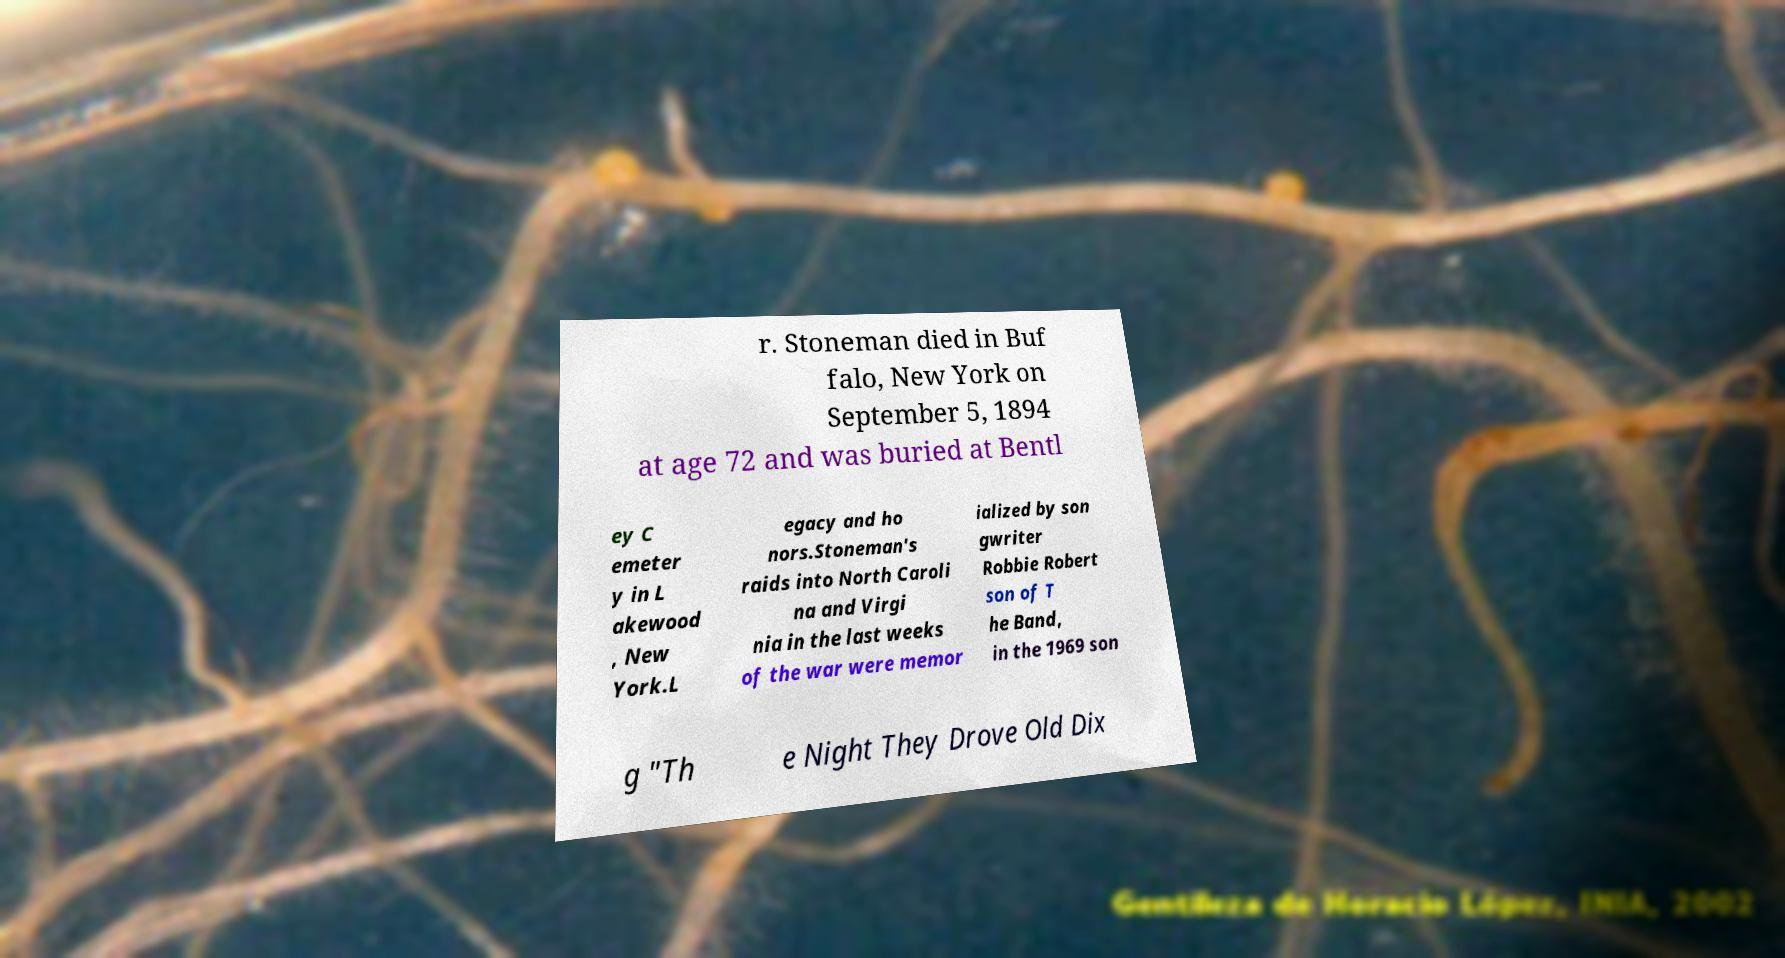Can you read and provide the text displayed in the image?This photo seems to have some interesting text. Can you extract and type it out for me? r. Stoneman died in Buf falo, New York on September 5, 1894 at age 72 and was buried at Bentl ey C emeter y in L akewood , New York.L egacy and ho nors.Stoneman's raids into North Caroli na and Virgi nia in the last weeks of the war were memor ialized by son gwriter Robbie Robert son of T he Band, in the 1969 son g "Th e Night They Drove Old Dix 